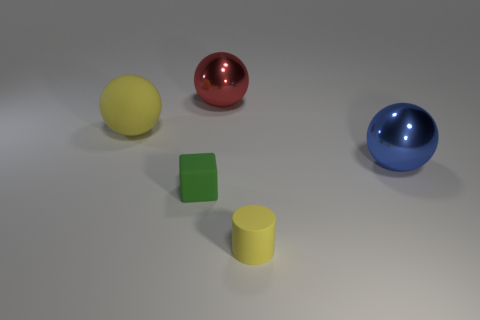Add 2 tiny rubber cubes. How many objects exist? 7 Subtract all cubes. How many objects are left? 4 Add 1 tiny blocks. How many tiny blocks are left? 2 Add 3 small green blocks. How many small green blocks exist? 4 Subtract 1 yellow cylinders. How many objects are left? 4 Subtract all blue metallic objects. Subtract all small cylinders. How many objects are left? 3 